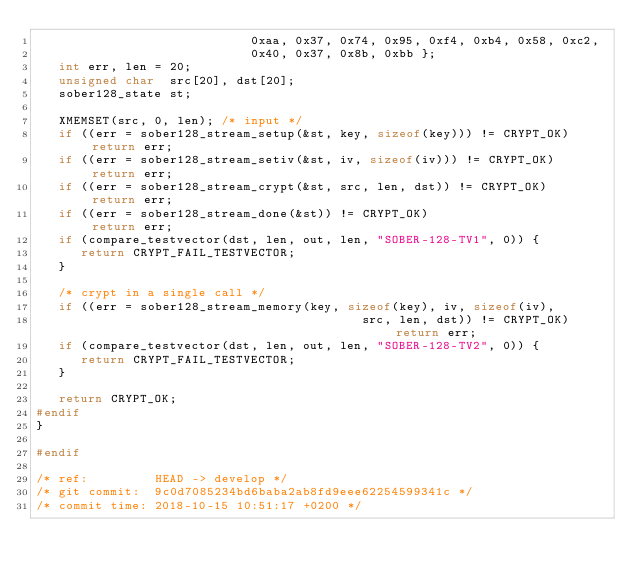Convert code to text. <code><loc_0><loc_0><loc_500><loc_500><_C_>                             0xaa, 0x37, 0x74, 0x95, 0xf4, 0xb4, 0x58, 0xc2,
                             0x40, 0x37, 0x8b, 0xbb };
   int err, len = 20;
   unsigned char  src[20], dst[20];
   sober128_state st;

   XMEMSET(src, 0, len); /* input */
   if ((err = sober128_stream_setup(&st, key, sizeof(key))) != CRYPT_OK) return err;
   if ((err = sober128_stream_setiv(&st, iv, sizeof(iv))) != CRYPT_OK)   return err;
   if ((err = sober128_stream_crypt(&st, src, len, dst)) != CRYPT_OK)    return err;
   if ((err = sober128_stream_done(&st)) != CRYPT_OK)                    return err;
   if (compare_testvector(dst, len, out, len, "SOBER-128-TV1", 0)) {
      return CRYPT_FAIL_TESTVECTOR;
   }

   /* crypt in a single call */
   if ((err = sober128_stream_memory(key, sizeof(key), iv, sizeof(iv),
                                            src, len, dst)) != CRYPT_OK) return err;
   if (compare_testvector(dst, len, out, len, "SOBER-128-TV2", 0)) {
      return CRYPT_FAIL_TESTVECTOR;
   }

   return CRYPT_OK;
#endif
}

#endif

/* ref:         HEAD -> develop */
/* git commit:  9c0d7085234bd6baba2ab8fd9eee62254599341c */
/* commit time: 2018-10-15 10:51:17 +0200 */
</code> 